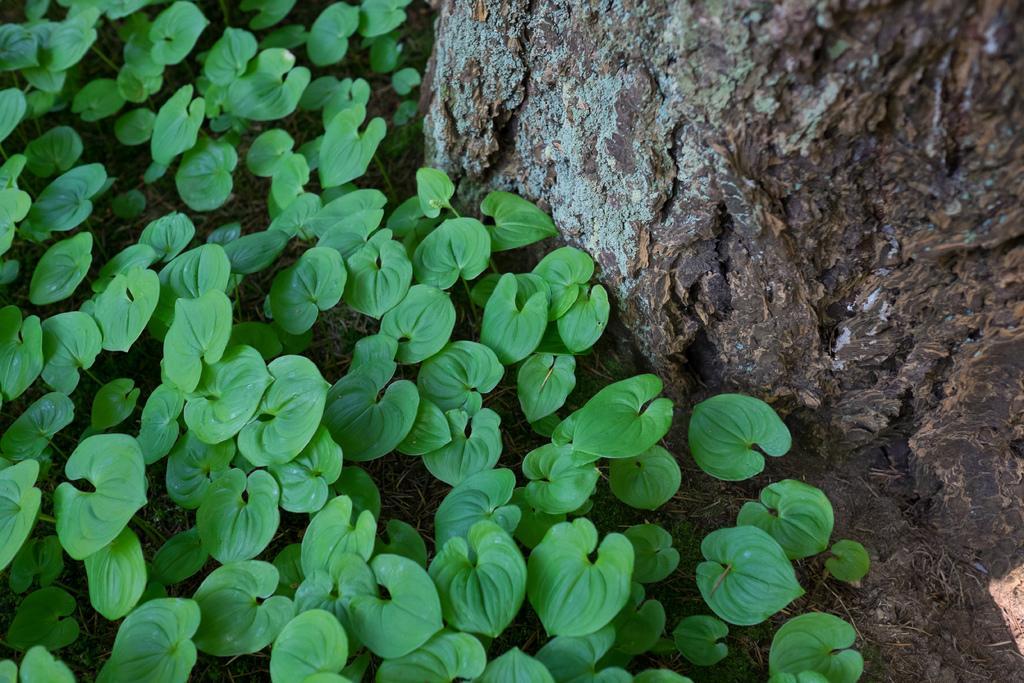In one or two sentences, can you explain what this image depicts? In the picture we can see a tree branch and beside it we can see full of leaves on the grass surface. 